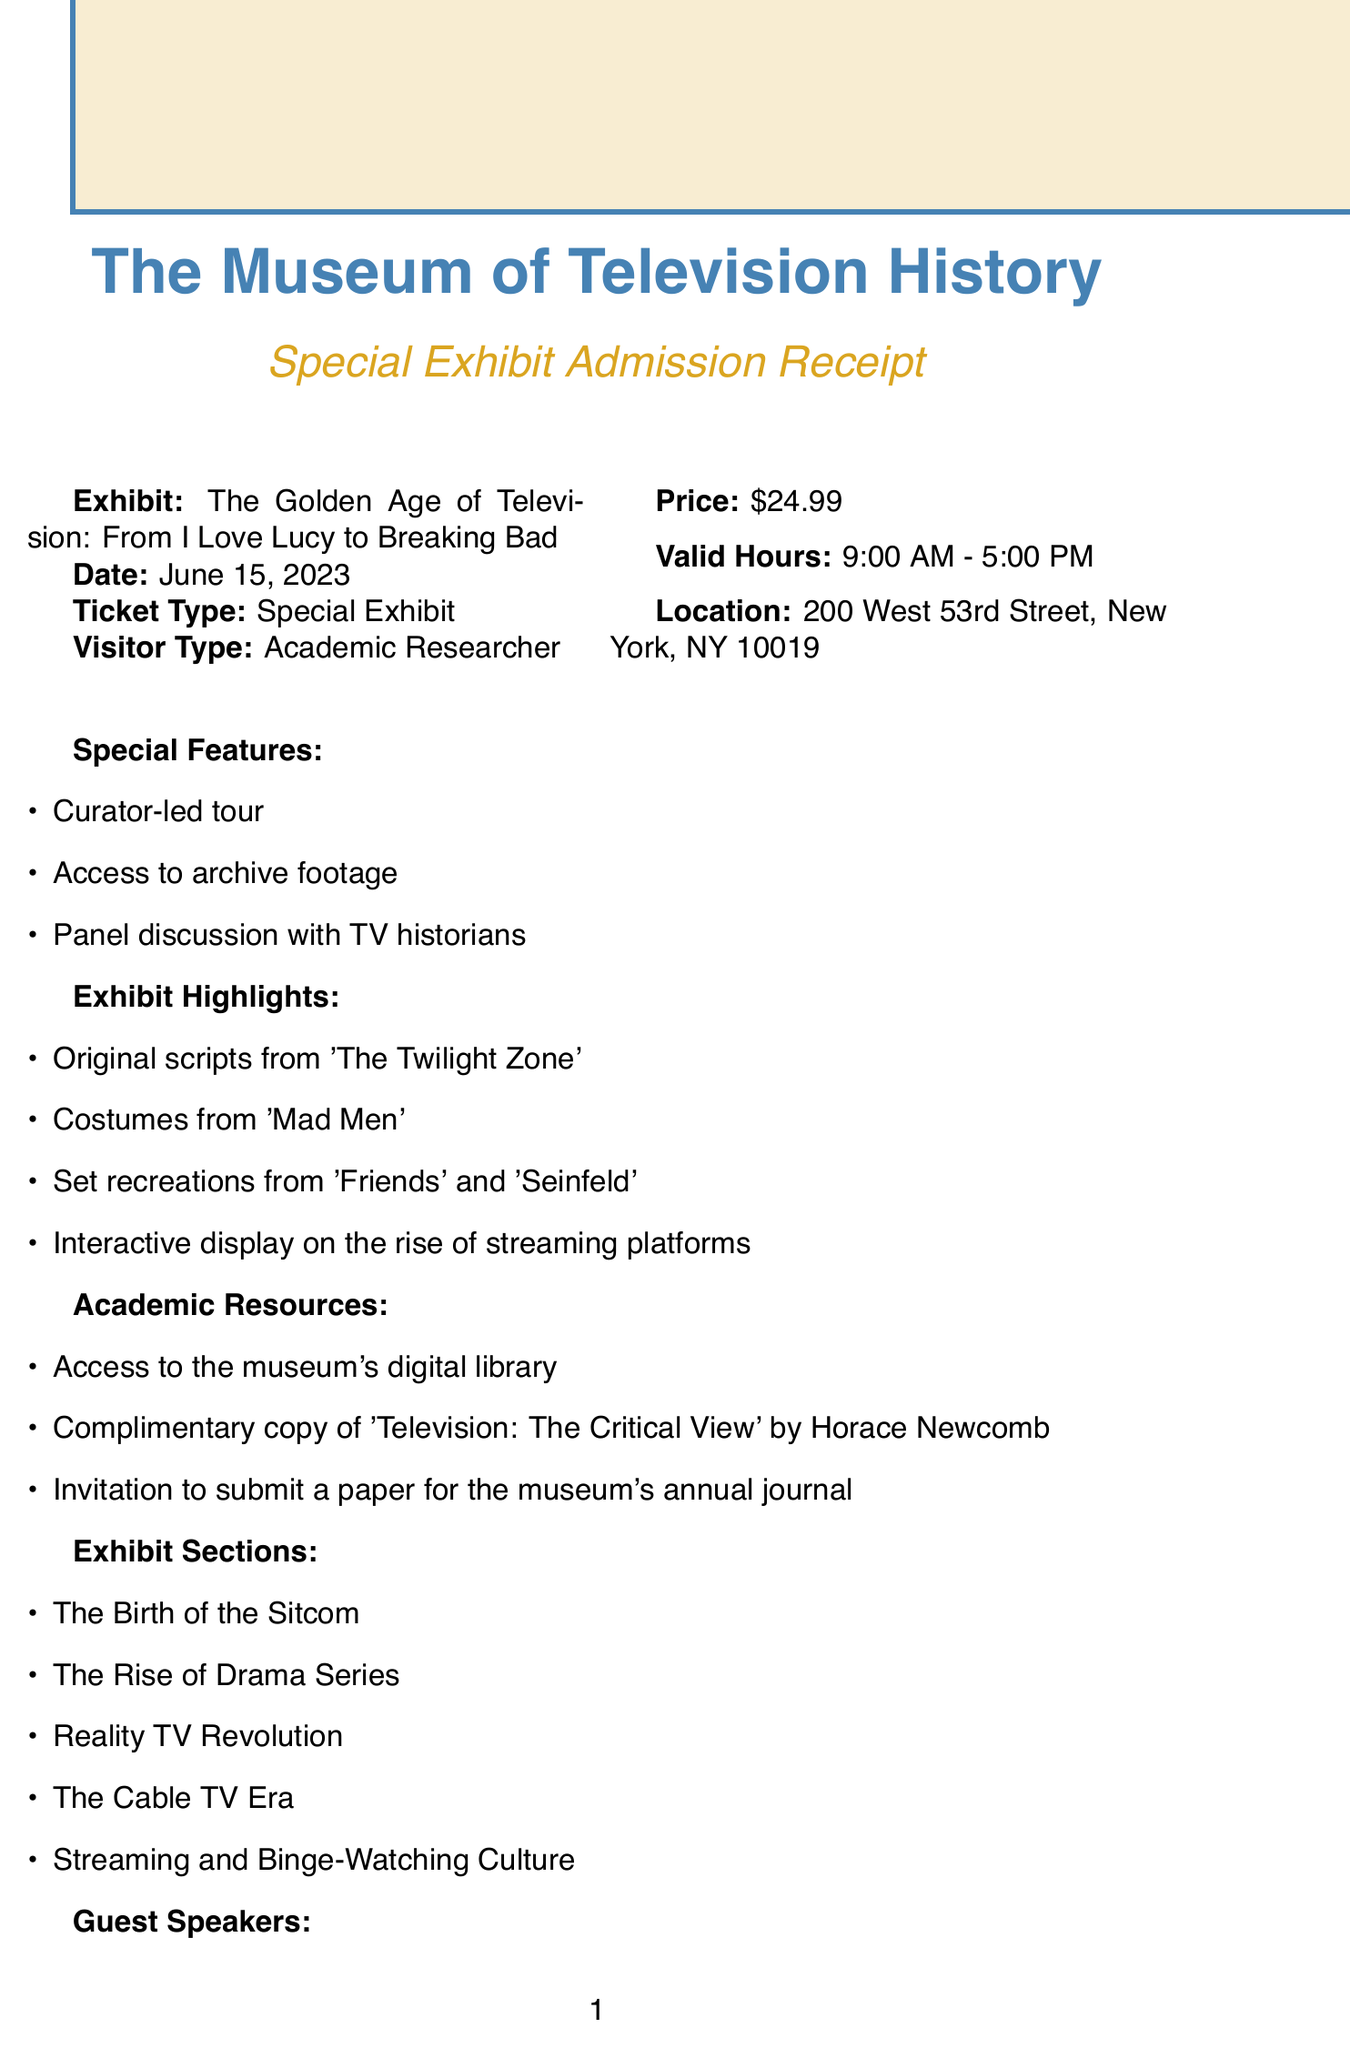What is the museum name? The museum name is listed prominently at the top of the document.
Answer: The Museum of Television History What is the price of the admission ticket? The document specifies the price under the admission details section.
Answer: $24.99 When is the admission date? The admission date is noted clearly in the document.
Answer: June 15, 2023 What are the special features included with the ticket? The document lists special features in a specific section.
Answer: Curator-led tour, Access to archive footage, Panel discussion with TV historians Who is one of the guest speakers? The document provides names of guest speakers in a dedicated section.
Answer: Dr. Robert Thompson, Syracuse University What is one exhibit highlight? The highlights of the exhibit are listed in the document.
Answer: Original scripts from 'The Twilight Zone' What is the visitor type mentioned? The visitor type is stated in the visitor information section.
Answer: Academic Researcher What kind of resources are provided to academic visitors? Resources available to academic visitors are listed in a specific section.
Answer: Access to the museum's digital library, Complimentary copy of 'Television: The Critical View' by Horace Newcomb, Invitation to submit a paper for the museum's annual journal What discount does the ticket provide at the gift shop? Additional information on the ticket mentions the discount in the document.
Answer: 10% discount 